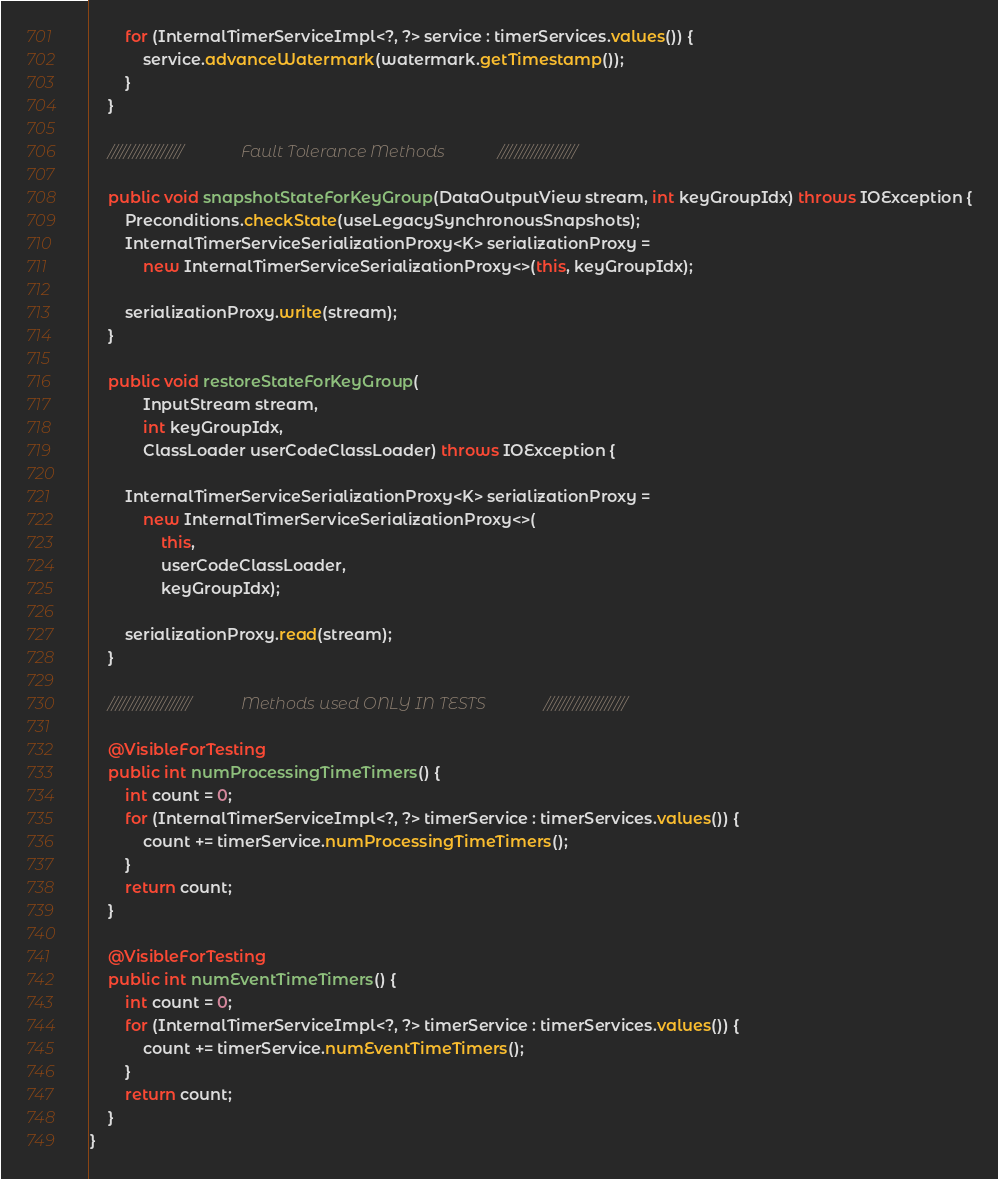<code> <loc_0><loc_0><loc_500><loc_500><_Java_>		for (InternalTimerServiceImpl<?, ?> service : timerServices.values()) {
			service.advanceWatermark(watermark.getTimestamp());
		}
	}

	//////////////////				Fault Tolerance Methods				///////////////////

	public void snapshotStateForKeyGroup(DataOutputView stream, int keyGroupIdx) throws IOException {
		Preconditions.checkState(useLegacySynchronousSnapshots);
		InternalTimerServiceSerializationProxy<K> serializationProxy =
			new InternalTimerServiceSerializationProxy<>(this, keyGroupIdx);

		serializationProxy.write(stream);
	}

	public void restoreStateForKeyGroup(
			InputStream stream,
			int keyGroupIdx,
			ClassLoader userCodeClassLoader) throws IOException {

		InternalTimerServiceSerializationProxy<K> serializationProxy =
			new InternalTimerServiceSerializationProxy<>(
				this,
				userCodeClassLoader,
				keyGroupIdx);

		serializationProxy.read(stream);
	}

	////////////////////			Methods used ONLY IN TESTS				////////////////////

	@VisibleForTesting
	public int numProcessingTimeTimers() {
		int count = 0;
		for (InternalTimerServiceImpl<?, ?> timerService : timerServices.values()) {
			count += timerService.numProcessingTimeTimers();
		}
		return count;
	}

	@VisibleForTesting
	public int numEventTimeTimers() {
		int count = 0;
		for (InternalTimerServiceImpl<?, ?> timerService : timerServices.values()) {
			count += timerService.numEventTimeTimers();
		}
		return count;
	}
}
</code> 